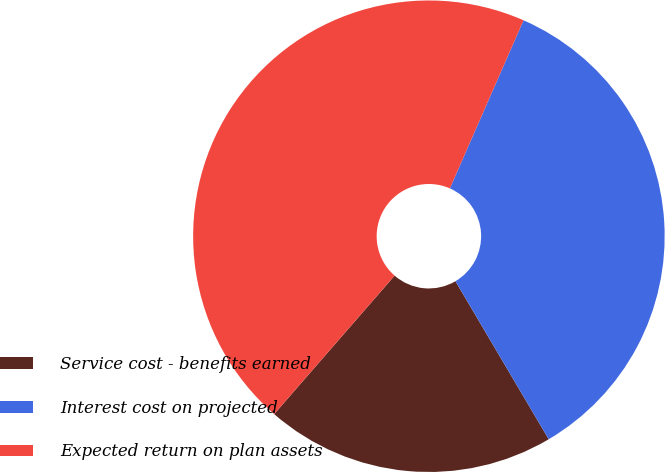<chart> <loc_0><loc_0><loc_500><loc_500><pie_chart><fcel>Service cost - benefits earned<fcel>Interest cost on projected<fcel>Expected return on plan assets<nl><fcel>19.88%<fcel>34.94%<fcel>45.18%<nl></chart> 